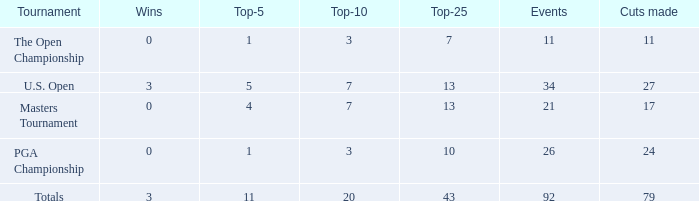Name the tournament for top-5 more thn 1 and top-25 of 13 with wins of 3 U.S. Open. 